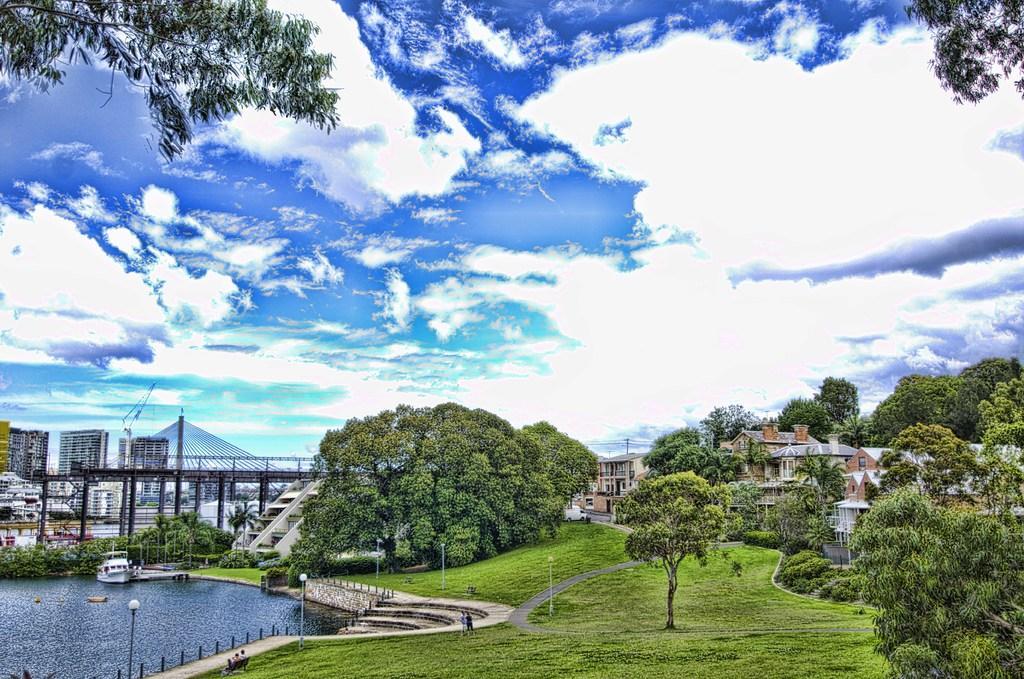In one or two sentences, can you explain what this image depicts? In this picture there is water and grassland at the bottom side of the image and there are buildings and trees in the background area of the image and there is a bridge in the background area of the image. 